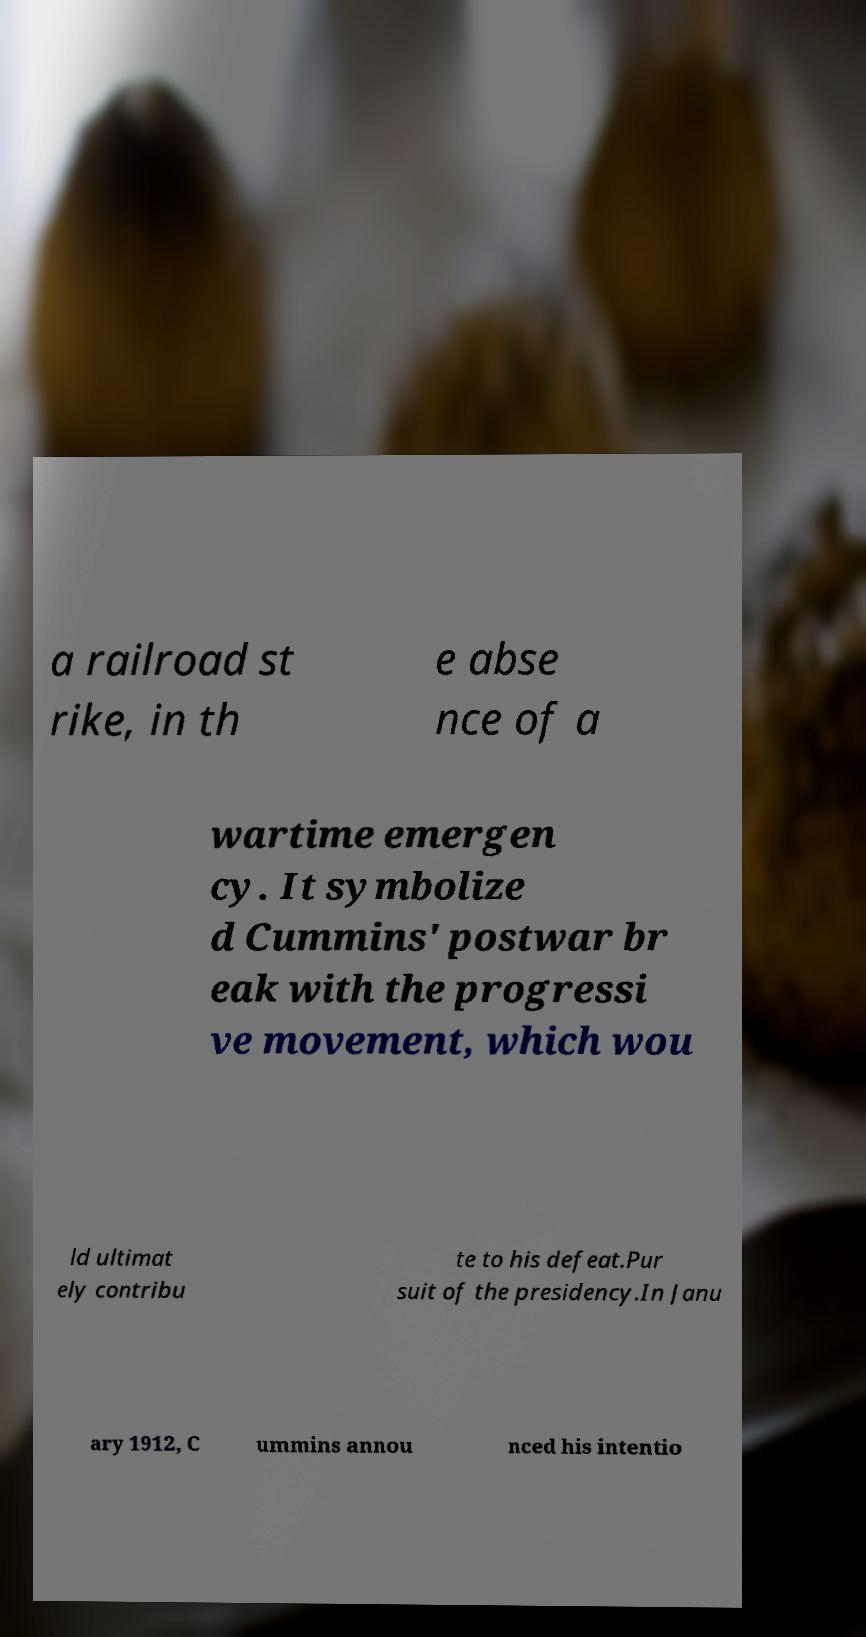Could you assist in decoding the text presented in this image and type it out clearly? a railroad st rike, in th e abse nce of a wartime emergen cy. It symbolize d Cummins' postwar br eak with the progressi ve movement, which wou ld ultimat ely contribu te to his defeat.Pur suit of the presidency.In Janu ary 1912, C ummins annou nced his intentio 